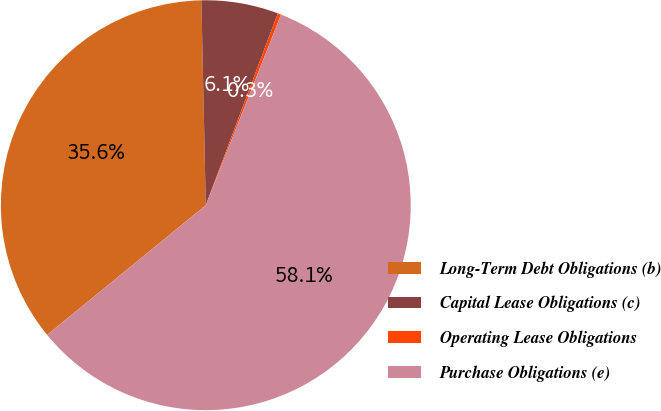<chart> <loc_0><loc_0><loc_500><loc_500><pie_chart><fcel>Long-Term Debt Obligations (b)<fcel>Capital Lease Obligations (c)<fcel>Operating Lease Obligations<fcel>Purchase Obligations (e)<nl><fcel>35.56%<fcel>6.06%<fcel>0.27%<fcel>58.11%<nl></chart> 